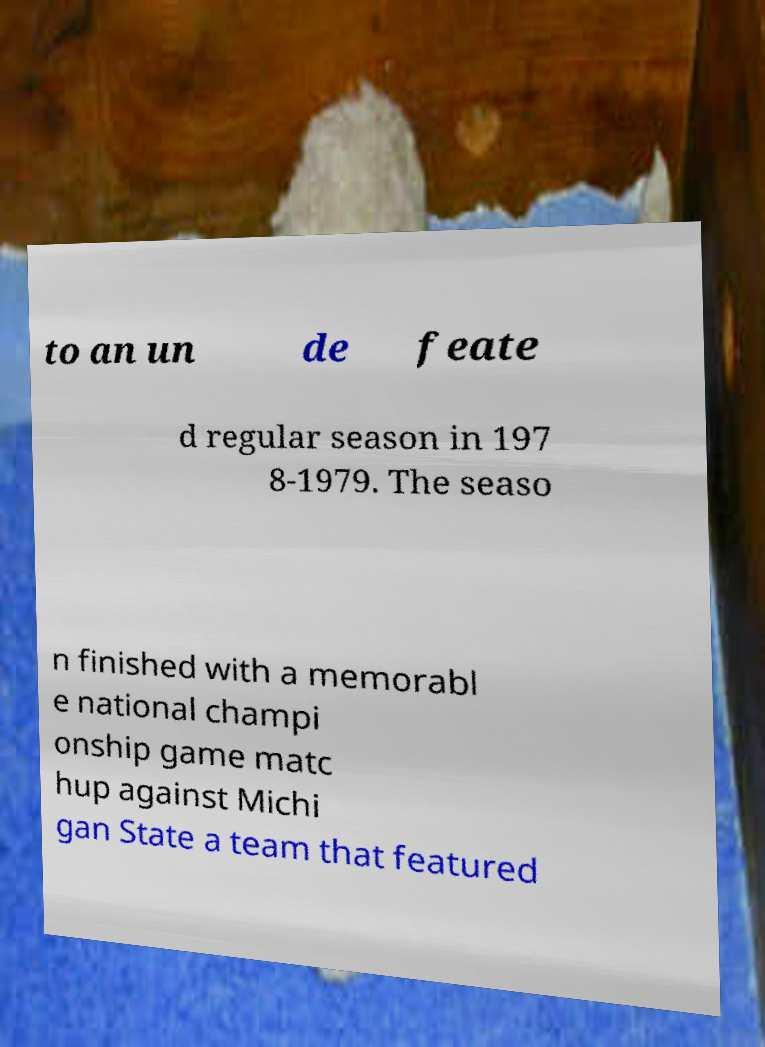Can you accurately transcribe the text from the provided image for me? to an un de feate d regular season in 197 8-1979. The seaso n finished with a memorabl e national champi onship game matc hup against Michi gan State a team that featured 